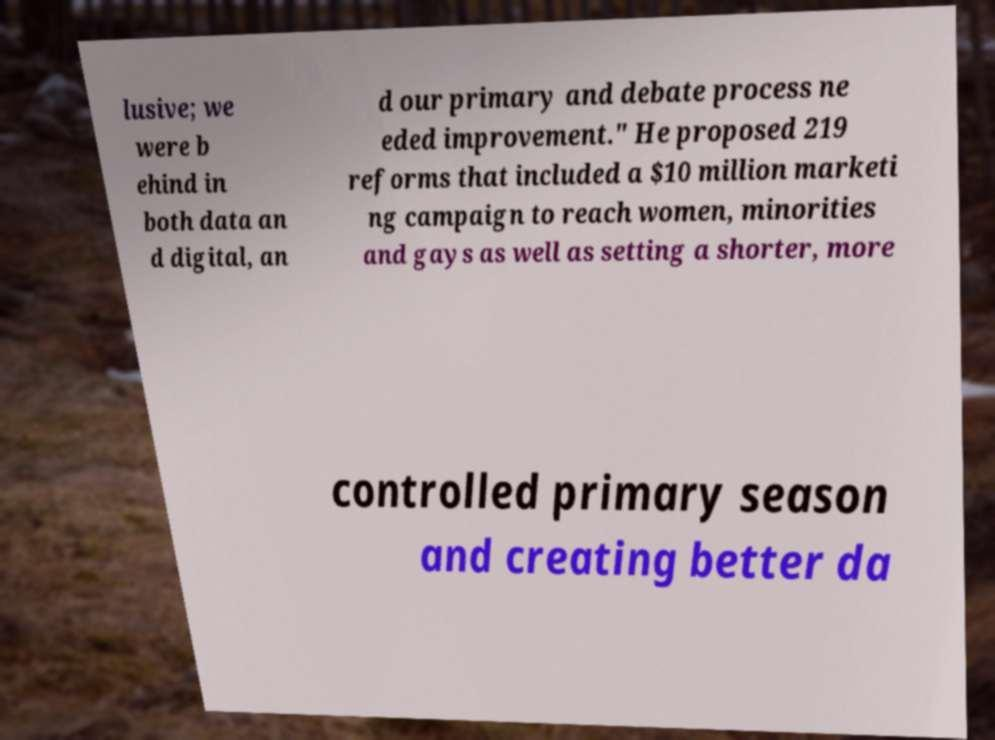Could you assist in decoding the text presented in this image and type it out clearly? lusive; we were b ehind in both data an d digital, an d our primary and debate process ne eded improvement." He proposed 219 reforms that included a $10 million marketi ng campaign to reach women, minorities and gays as well as setting a shorter, more controlled primary season and creating better da 